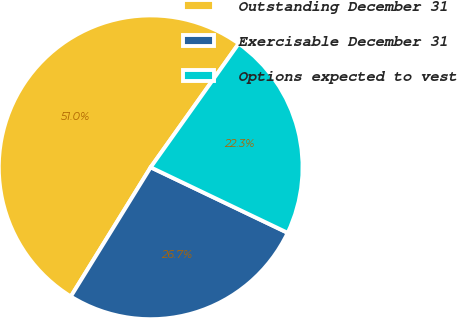Convert chart to OTSL. <chart><loc_0><loc_0><loc_500><loc_500><pie_chart><fcel>Outstanding December 31<fcel>Exercisable December 31<fcel>Options expected to vest<nl><fcel>51.03%<fcel>26.71%<fcel>22.26%<nl></chart> 